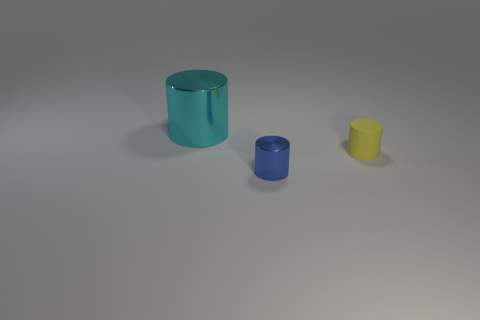Subtract all shiny cylinders. How many cylinders are left? 1 Add 2 large cyan metal objects. How many objects exist? 5 Subtract all blue cylinders. How many cylinders are left? 2 Subtract 1 cylinders. How many cylinders are left? 2 Subtract all green cylinders. Subtract all yellow cubes. How many cylinders are left? 3 Subtract all blue balls. How many blue cylinders are left? 1 Add 1 large cyan objects. How many large cyan objects are left? 2 Add 1 small matte cylinders. How many small matte cylinders exist? 2 Subtract 1 cyan cylinders. How many objects are left? 2 Subtract all small blue things. Subtract all cyan shiny objects. How many objects are left? 1 